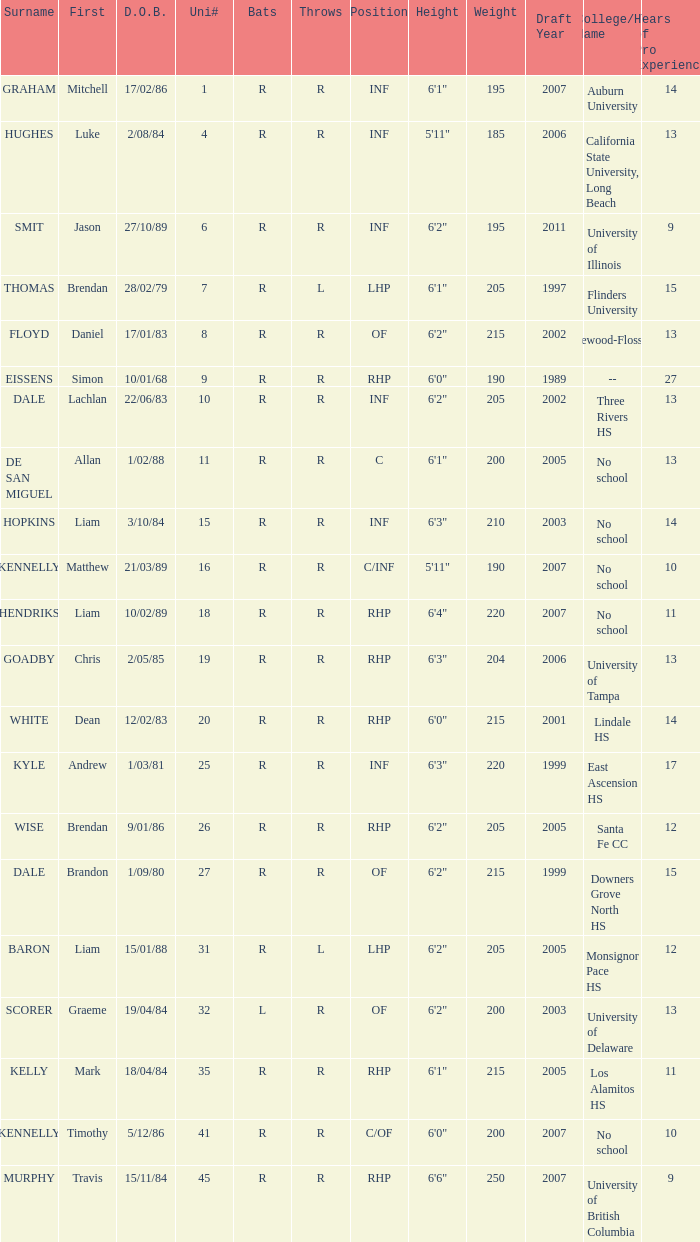Which hitter has a uni# 31? R. 